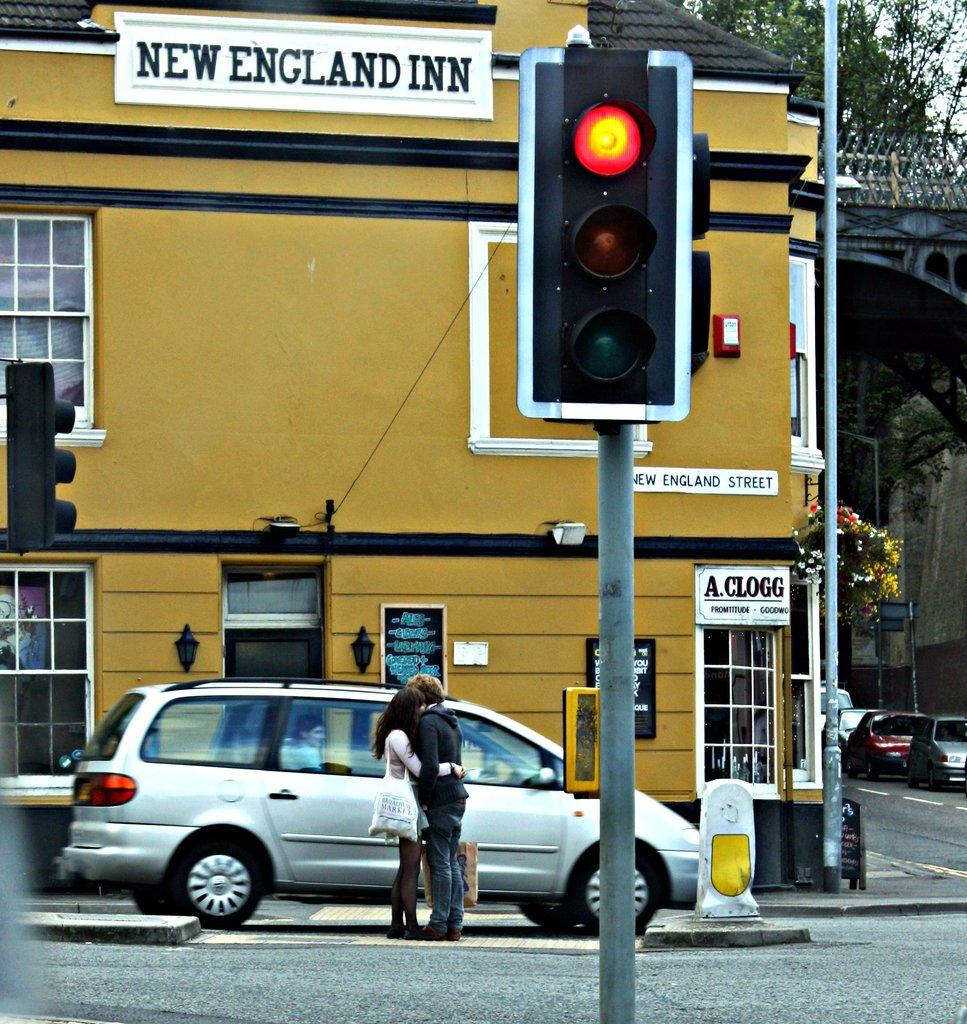<image>
Offer a succinct explanation of the picture presented. A sign that reads New England Inn on the side of a traffic light. 